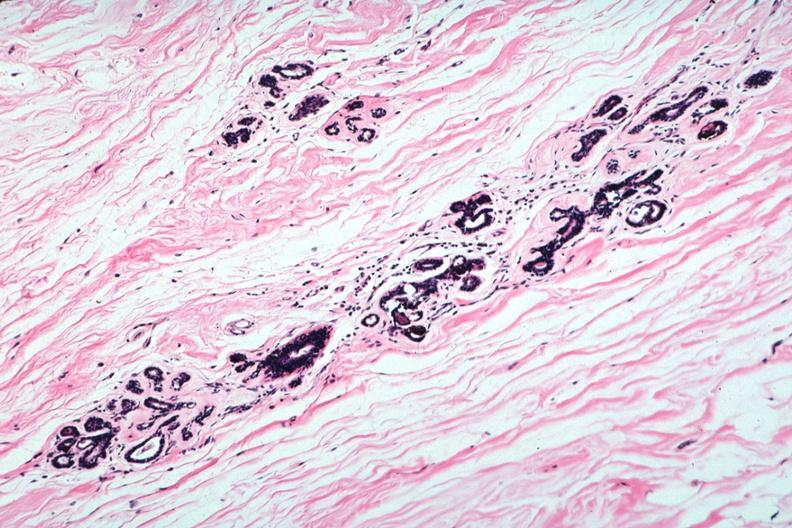s breast present?
Answer the question using a single word or phrase. Yes 